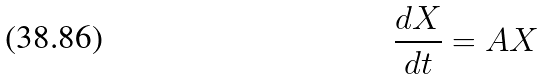<formula> <loc_0><loc_0><loc_500><loc_500>\frac { d X } { d t } = A X</formula> 